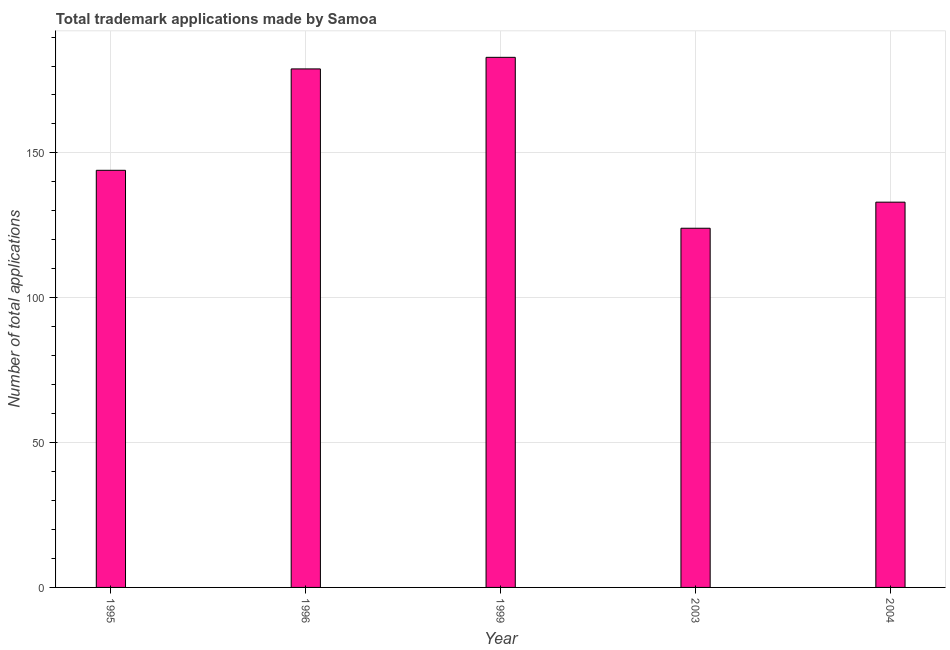Does the graph contain any zero values?
Your response must be concise. No. Does the graph contain grids?
Give a very brief answer. Yes. What is the title of the graph?
Ensure brevity in your answer.  Total trademark applications made by Samoa. What is the label or title of the X-axis?
Ensure brevity in your answer.  Year. What is the label or title of the Y-axis?
Give a very brief answer. Number of total applications. What is the number of trademark applications in 1999?
Give a very brief answer. 183. Across all years, what is the maximum number of trademark applications?
Your answer should be compact. 183. Across all years, what is the minimum number of trademark applications?
Keep it short and to the point. 124. What is the sum of the number of trademark applications?
Offer a very short reply. 763. What is the average number of trademark applications per year?
Provide a succinct answer. 152. What is the median number of trademark applications?
Provide a succinct answer. 144. In how many years, is the number of trademark applications greater than 60 ?
Make the answer very short. 5. Do a majority of the years between 1999 and 2003 (inclusive) have number of trademark applications greater than 170 ?
Ensure brevity in your answer.  No. What is the ratio of the number of trademark applications in 1995 to that in 2004?
Give a very brief answer. 1.08. Is the number of trademark applications in 1995 less than that in 1996?
Give a very brief answer. Yes. What is the difference between the highest and the second highest number of trademark applications?
Your response must be concise. 4. Is the sum of the number of trademark applications in 2003 and 2004 greater than the maximum number of trademark applications across all years?
Offer a terse response. Yes. How many bars are there?
Your answer should be very brief. 5. How many years are there in the graph?
Make the answer very short. 5. Are the values on the major ticks of Y-axis written in scientific E-notation?
Offer a terse response. No. What is the Number of total applications in 1995?
Keep it short and to the point. 144. What is the Number of total applications in 1996?
Provide a succinct answer. 179. What is the Number of total applications of 1999?
Your response must be concise. 183. What is the Number of total applications of 2003?
Your response must be concise. 124. What is the Number of total applications of 2004?
Your answer should be very brief. 133. What is the difference between the Number of total applications in 1995 and 1996?
Your answer should be compact. -35. What is the difference between the Number of total applications in 1995 and 1999?
Offer a terse response. -39. What is the difference between the Number of total applications in 1996 and 1999?
Ensure brevity in your answer.  -4. What is the difference between the Number of total applications in 1996 and 2004?
Your answer should be very brief. 46. What is the difference between the Number of total applications in 1999 and 2003?
Offer a very short reply. 59. What is the difference between the Number of total applications in 2003 and 2004?
Provide a succinct answer. -9. What is the ratio of the Number of total applications in 1995 to that in 1996?
Keep it short and to the point. 0.8. What is the ratio of the Number of total applications in 1995 to that in 1999?
Your answer should be very brief. 0.79. What is the ratio of the Number of total applications in 1995 to that in 2003?
Your response must be concise. 1.16. What is the ratio of the Number of total applications in 1995 to that in 2004?
Keep it short and to the point. 1.08. What is the ratio of the Number of total applications in 1996 to that in 2003?
Offer a very short reply. 1.44. What is the ratio of the Number of total applications in 1996 to that in 2004?
Provide a short and direct response. 1.35. What is the ratio of the Number of total applications in 1999 to that in 2003?
Ensure brevity in your answer.  1.48. What is the ratio of the Number of total applications in 1999 to that in 2004?
Keep it short and to the point. 1.38. What is the ratio of the Number of total applications in 2003 to that in 2004?
Your response must be concise. 0.93. 